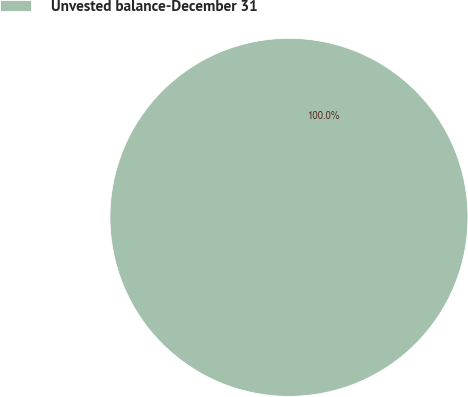Convert chart to OTSL. <chart><loc_0><loc_0><loc_500><loc_500><pie_chart><fcel>Unvested balance-December 31<nl><fcel>100.0%<nl></chart> 